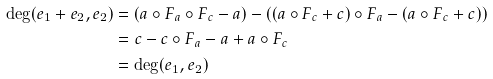Convert formula to latex. <formula><loc_0><loc_0><loc_500><loc_500>\deg ( e _ { 1 } + e _ { 2 } , e _ { 2 } ) & = ( a \circ F _ { a } \circ F _ { c } - a ) - ( ( a \circ F _ { c } + c ) \circ F _ { a } - ( a \circ F _ { c } + c ) ) \\ & = c - c \circ F _ { a } - a + a \circ F _ { c } \\ & = \deg ( e _ { 1 } , e _ { 2 } )</formula> 